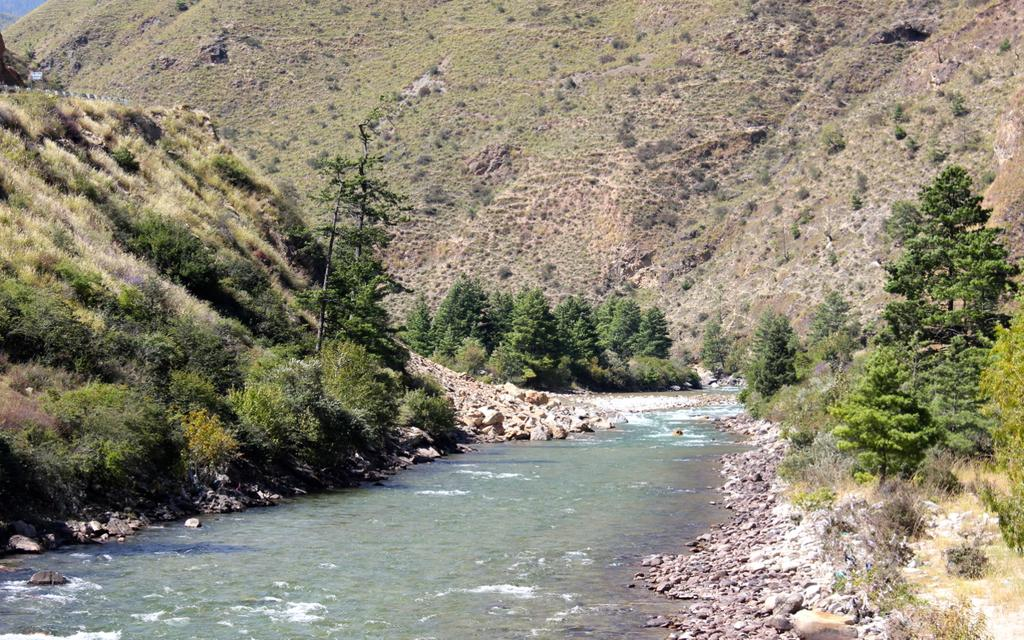What geographical feature is the main subject of the image? There is a mountain in the image. What type of vegetation can be seen in the image? There are trees in the image. Where is the railing located in the image? The railing is at the top left of the image. What object can be seen in the image that might be used for displaying information or messages? There is a board in the image. What natural element is present at the bottom of the image? There is water at the bottom of the image. What type of objects can be seen in the water? There are stones in the water. How long does it take for the mountain to move in the image? The mountain does not move in the image; it is a stationary geographical feature. Can you tell me how many seats are available on the mountain in the image? There are no seats present on the mountain in the image. 